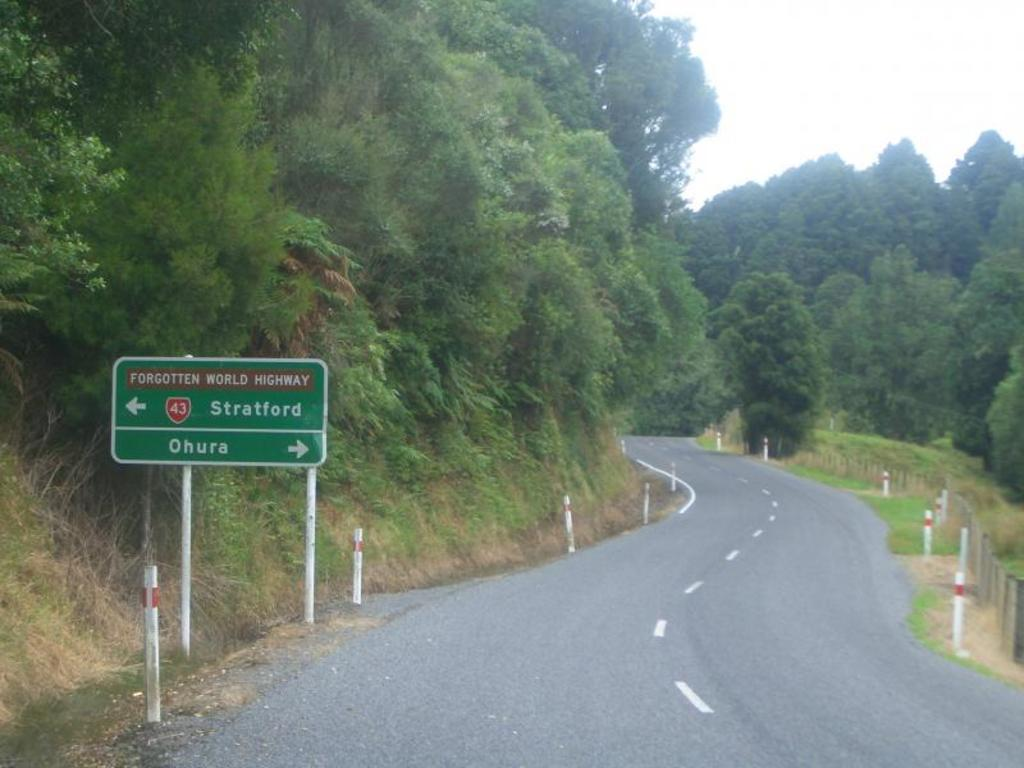Provide a one-sentence caption for the provided image. a sign next to the road that says Stratford. 